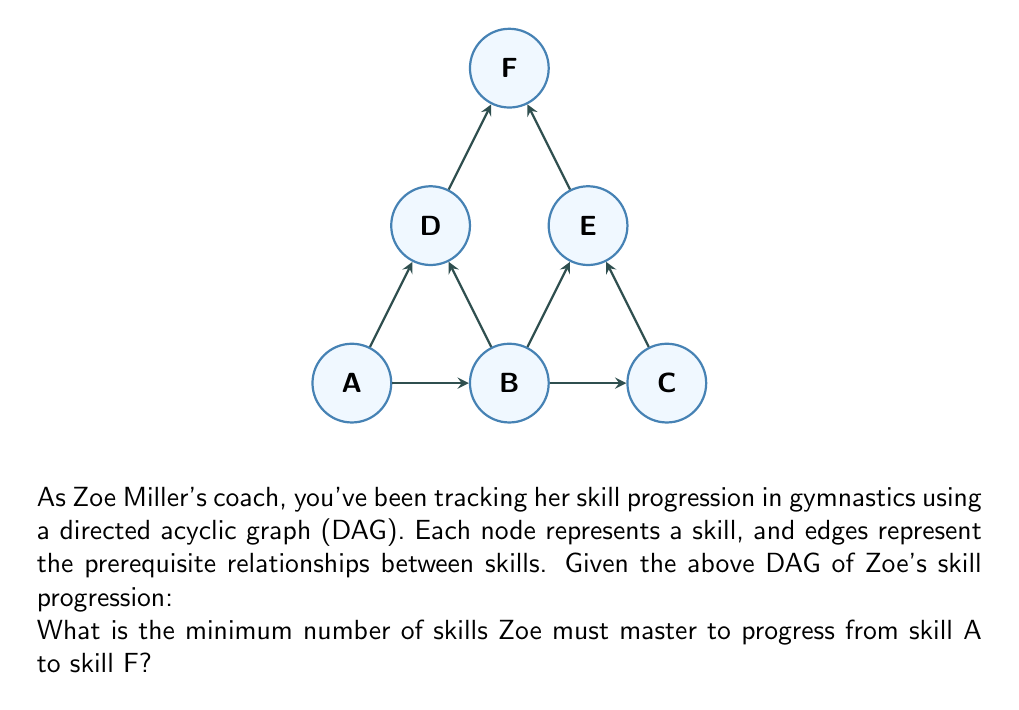Provide a solution to this math problem. Let's approach this step-by-step:

1) In a DAG representing skill progression, the minimum number of skills required to get from one skill to another is equal to the length of the longest path between those skills, plus one (to include the starting skill).

2) To find the longest path from A to F, we need to consider all possible paths:

   Path 1: A → B → C → E → F
   Path 2: A → B → D → F
   Path 3: A → D → F

3) Let's count the number of edges in each path:

   Path 1: 4 edges
   Path 2: 3 edges
   Path 3: 2 edges

4) The longest path is Path 1, with 4 edges.

5) To get the minimum number of skills, we add 1 to the number of edges in the longest path:

   $$\text{Minimum number of skills} = \text{Longest path length} + 1 = 4 + 1 = 5$$

Therefore, Zoe must master a minimum of 5 skills to progress from A to F.
Answer: 5 skills 